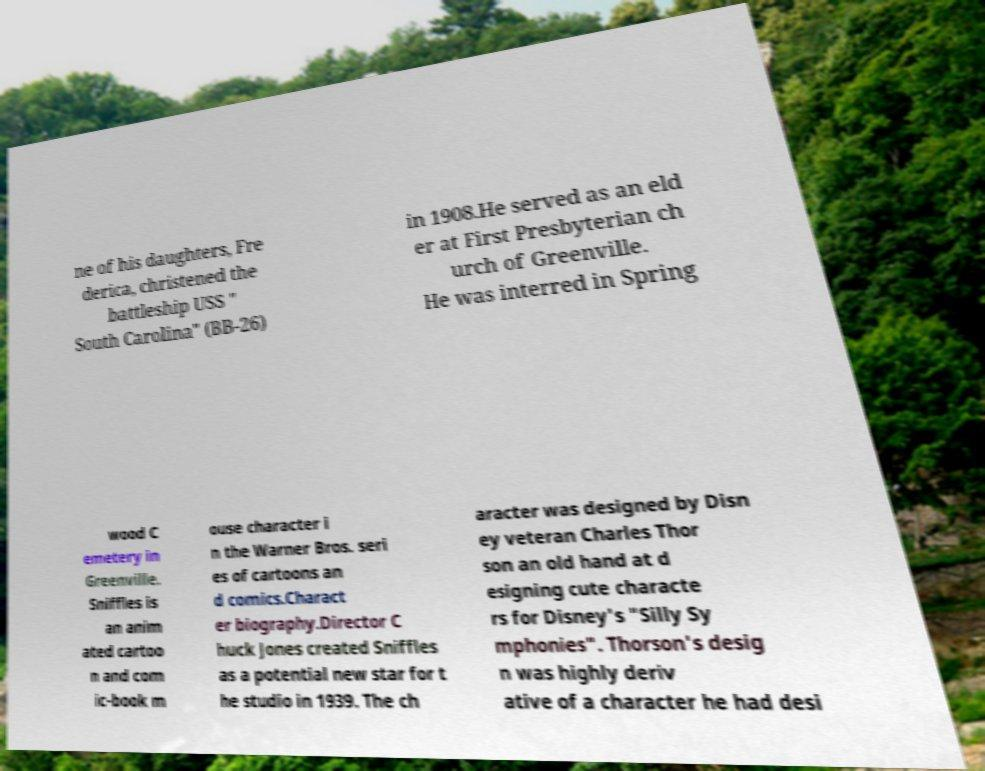What messages or text are displayed in this image? I need them in a readable, typed format. ne of his daughters, Fre derica, christened the battleship USS " South Carolina" (BB-26) in 1908.He served as an eld er at First Presbyterian ch urch of Greenville. He was interred in Spring wood C emetery in Greenville. Sniffles is an anim ated cartoo n and com ic-book m ouse character i n the Warner Bros. seri es of cartoons an d comics.Charact er biography.Director C huck Jones created Sniffles as a potential new star for t he studio in 1939. The ch aracter was designed by Disn ey veteran Charles Thor son an old hand at d esigning cute characte rs for Disney's "Silly Sy mphonies". Thorson's desig n was highly deriv ative of a character he had desi 